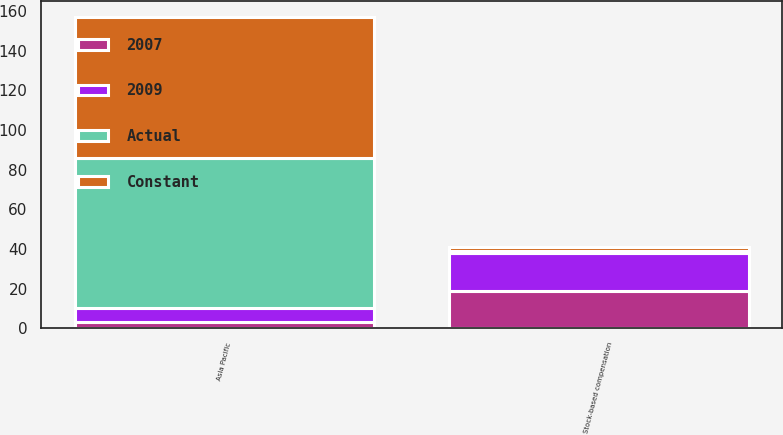<chart> <loc_0><loc_0><loc_500><loc_500><stacked_bar_chart><ecel><fcel>Asia Pacific<fcel>Stock-based compensation<nl><fcel>Constant<fcel>71<fcel>2<nl><fcel>2009<fcel>7<fcel>19<nl><fcel>2007<fcel>3<fcel>19<nl><fcel>Actual<fcel>76<fcel>1<nl></chart> 